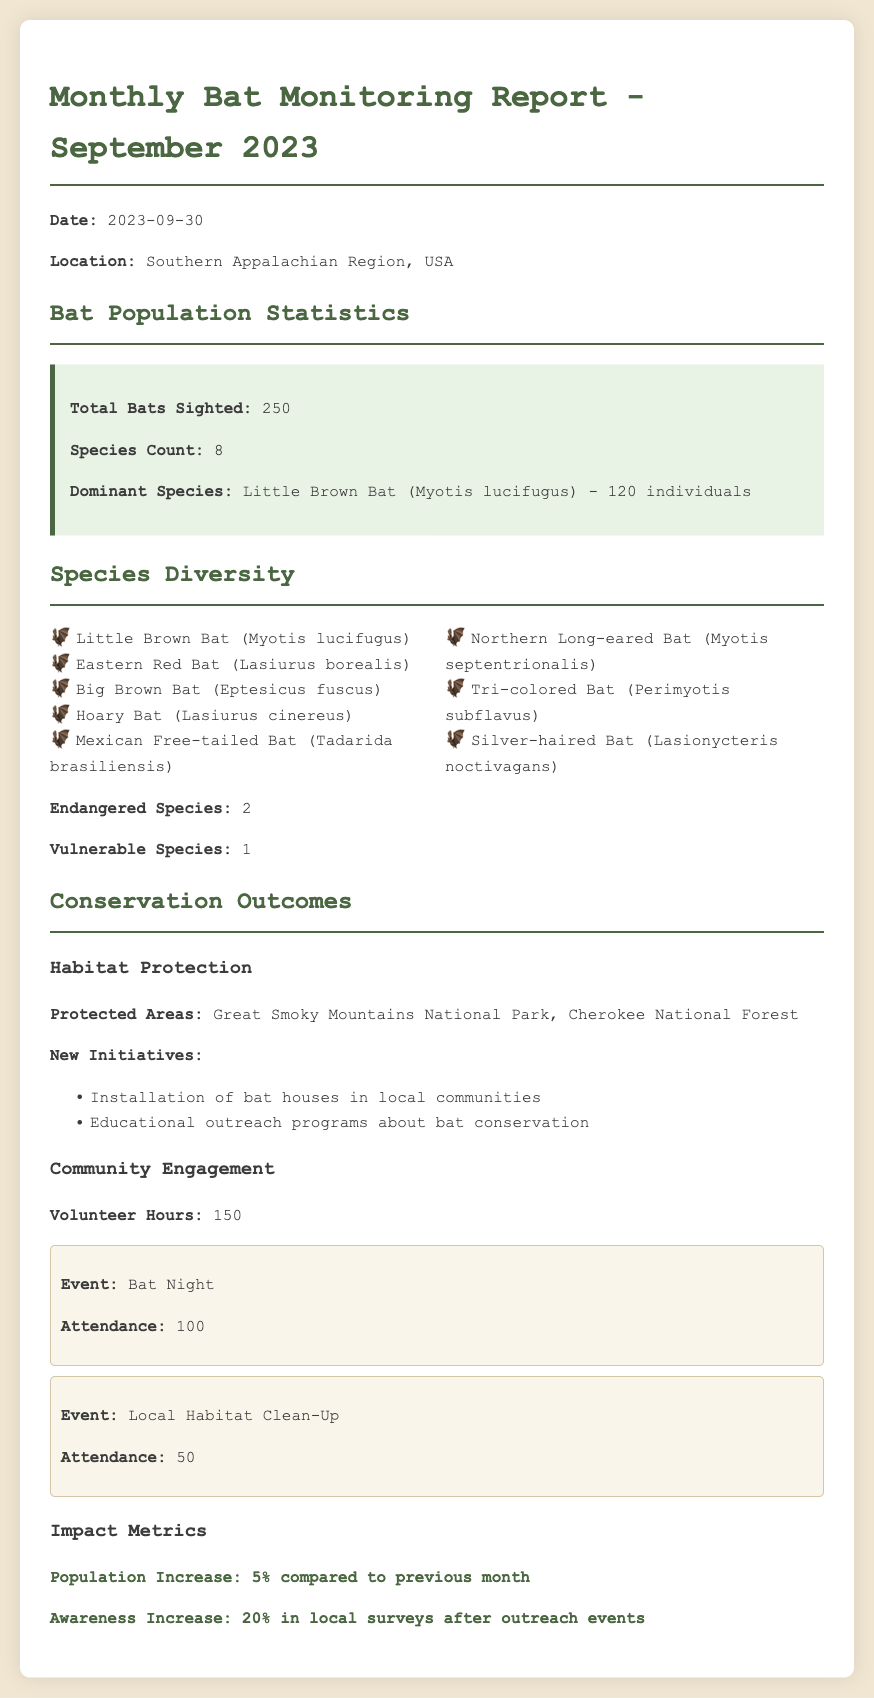What is the total number of bats sighted? The total number of bats sighted in the report is explicitly mentioned in the population statistics section.
Answer: 250 What are the endangered species observed? The document states that there are 2 endangered species noted under species diversity.
Answer: 2 What is the dominant species? The document identifies the dominant species and its count in the population statistics section.
Answer: Little Brown Bat (Myotis lucifugus) - 120 individuals How many species were recorded in total? The species count is summarized in the population statistics section of the report.
Answer: 8 What was the percentage increase in population compared to the previous month? The population increase percentage is specifically mentioned in the impact metrics section of the report.
Answer: 5% What new conservation initiative was mentioned? The document lists initiatives related to habitat protection; one example can be found in the conservation outcomes section.
Answer: Installation of bat houses in local communities What was the attendance for Bat Night? The attendance figures are provided in the community engagement section of the report for specific events.
Answer: 100 How many volunteer hours were recorded? The document clearly states the number of volunteer hours in the community engagement section.
Answer: 150 What was the impact on awareness after outreach events? The increase in awareness percentage is outlined in the impact metrics section of the report.
Answer: 20% 